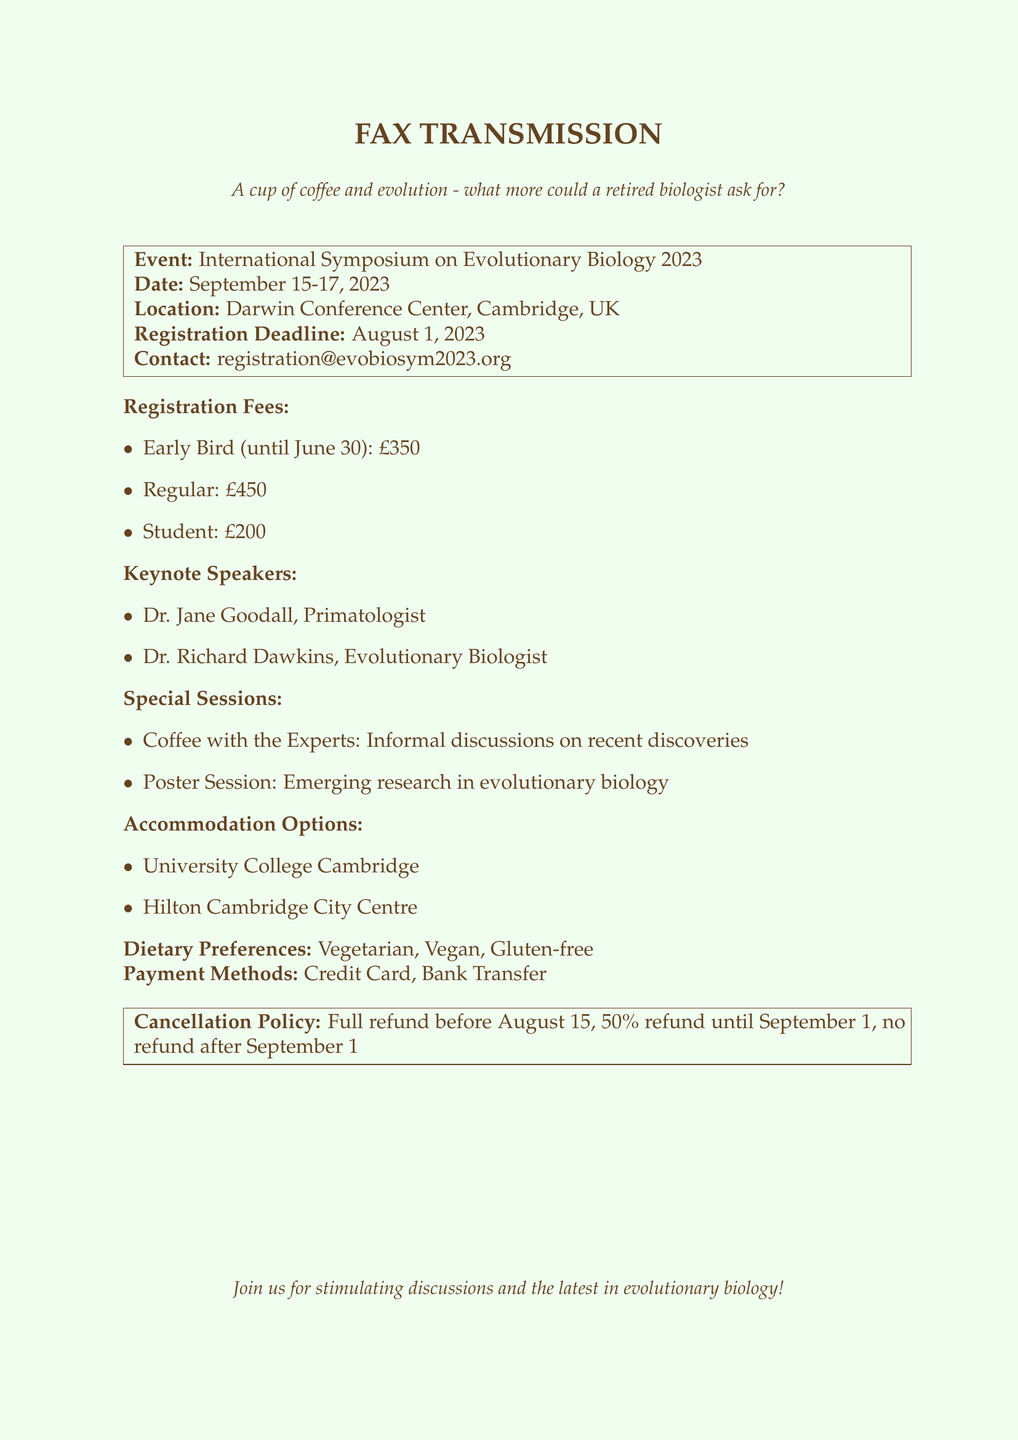what are the registration fees for students? The registration fees for students are specifically listed in the document, which states student fees as £200.
Answer: £200 who is the keynote speaker that is a primatologist? The document lists Dr. Jane Goodall as one of the keynote speakers and specifies her profession as a primatologist.
Answer: Dr. Jane Goodall what is the cancellation policy before August 15? The cancellation policy states that a full refund is available before August 15.
Answer: Full refund where is the symposium taking place? The document provides the location of the event, which is the Darwin Conference Center, Cambridge, UK.
Answer: Darwin Conference Center, Cambridge, UK what are the payment methods available? The document details two payment methods for registration: Credit Card and Bank Transfer.
Answer: Credit Card, Bank Transfer what is the registration deadline? The registration deadline is explicitly mentioned in the document as August 1, 2023.
Answer: August 1, 2023 what special session involves informal discussions? The document describes a special session titled "Coffee with the Experts" that includes informal discussions on recent discoveries.
Answer: Coffee with the Experts what dietary preferences are accommodated? The document lists the dietary preferences catered for the symposium, including Vegetarian, Vegan, and Gluten-free options.
Answer: Vegetarian, Vegan, Gluten-free 